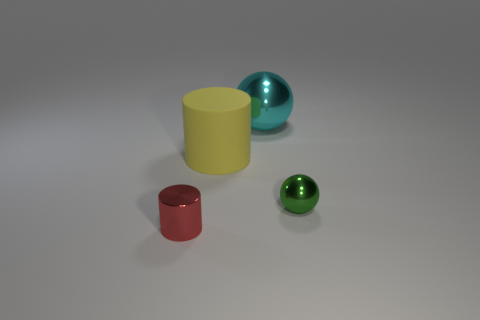Does the object that is right of the big cyan sphere have the same color as the thing in front of the small ball?
Provide a succinct answer. No. Are there any other large metallic things of the same shape as the large cyan thing?
Provide a short and direct response. No. There is another object that is the same size as the yellow rubber object; what shape is it?
Your answer should be very brief. Sphere. What is the size of the cylinder that is behind the tiny red metallic object?
Your response must be concise. Large. How many cyan matte cylinders have the same size as the red cylinder?
Keep it short and to the point. 0. The tiny ball that is the same material as the cyan thing is what color?
Offer a very short reply. Green. Is the number of rubber things behind the green shiny object less than the number of large purple metal spheres?
Your response must be concise. No. There is a green thing that is made of the same material as the large ball; what is its shape?
Ensure brevity in your answer.  Sphere. What number of metal objects are tiny green spheres or brown cylinders?
Your response must be concise. 1. Are there an equal number of large shiny balls that are on the right side of the cyan shiny ball and large green metallic balls?
Your response must be concise. Yes. 